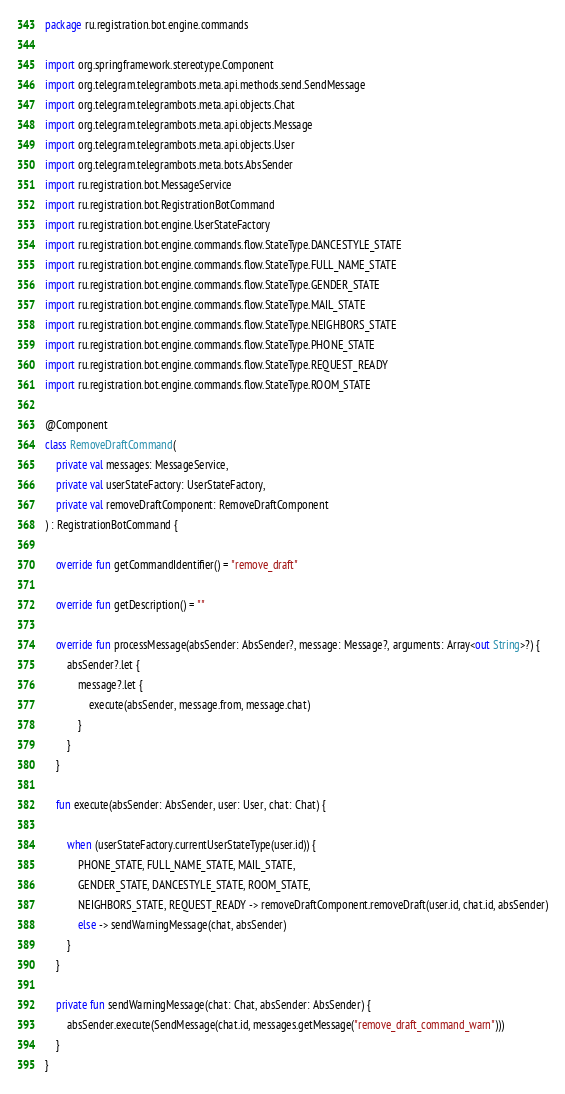Convert code to text. <code><loc_0><loc_0><loc_500><loc_500><_Kotlin_>package ru.registration.bot.engine.commands

import org.springframework.stereotype.Component
import org.telegram.telegrambots.meta.api.methods.send.SendMessage
import org.telegram.telegrambots.meta.api.objects.Chat
import org.telegram.telegrambots.meta.api.objects.Message
import org.telegram.telegrambots.meta.api.objects.User
import org.telegram.telegrambots.meta.bots.AbsSender
import ru.registration.bot.MessageService
import ru.registration.bot.RegistrationBotCommand
import ru.registration.bot.engine.UserStateFactory
import ru.registration.bot.engine.commands.flow.StateType.DANCESTYLE_STATE
import ru.registration.bot.engine.commands.flow.StateType.FULL_NAME_STATE
import ru.registration.bot.engine.commands.flow.StateType.GENDER_STATE
import ru.registration.bot.engine.commands.flow.StateType.MAIL_STATE
import ru.registration.bot.engine.commands.flow.StateType.NEIGHBORS_STATE
import ru.registration.bot.engine.commands.flow.StateType.PHONE_STATE
import ru.registration.bot.engine.commands.flow.StateType.REQUEST_READY
import ru.registration.bot.engine.commands.flow.StateType.ROOM_STATE

@Component
class RemoveDraftCommand(
    private val messages: MessageService,
    private val userStateFactory: UserStateFactory,
    private val removeDraftComponent: RemoveDraftComponent
) : RegistrationBotCommand {

    override fun getCommandIdentifier() = "remove_draft"

    override fun getDescription() = ""

    override fun processMessage(absSender: AbsSender?, message: Message?, arguments: Array<out String>?) {
        absSender?.let {
            message?.let {
                execute(absSender, message.from, message.chat)
            }
        }
    }

    fun execute(absSender: AbsSender, user: User, chat: Chat) {

        when (userStateFactory.currentUserStateType(user.id)) {
            PHONE_STATE, FULL_NAME_STATE, MAIL_STATE,
            GENDER_STATE, DANCESTYLE_STATE, ROOM_STATE,
            NEIGHBORS_STATE, REQUEST_READY -> removeDraftComponent.removeDraft(user.id, chat.id, absSender)
            else -> sendWarningMessage(chat, absSender)
        }
    }

    private fun sendWarningMessage(chat: Chat, absSender: AbsSender) {
        absSender.execute(SendMessage(chat.id, messages.getMessage("remove_draft_command_warn")))
    }
}
</code> 